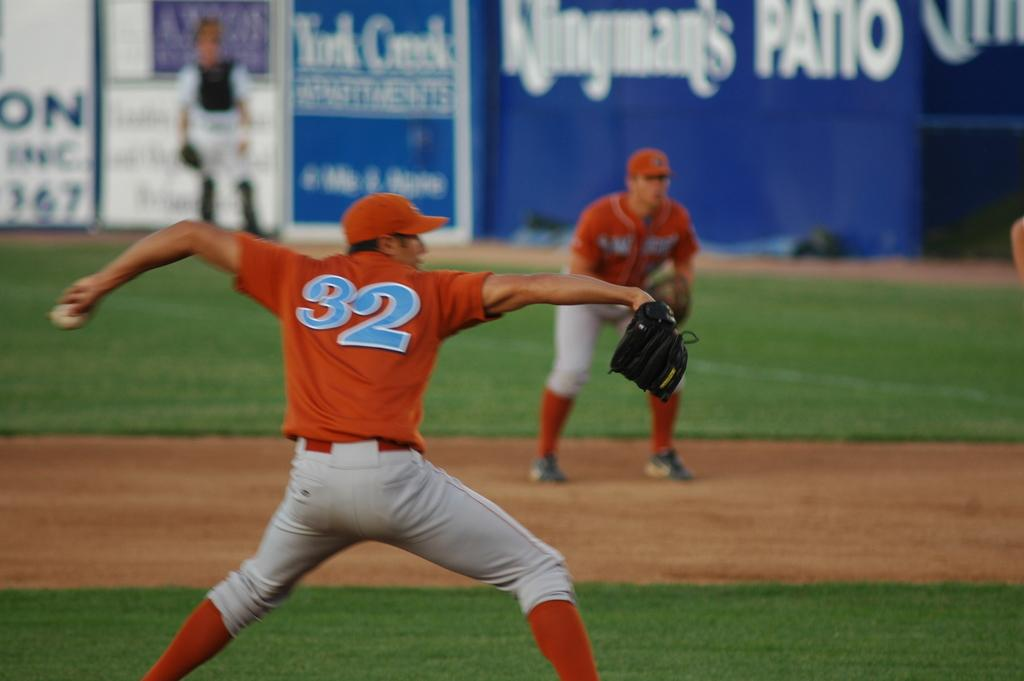<image>
Create a compact narrative representing the image presented. A player with the number 32 on his back 